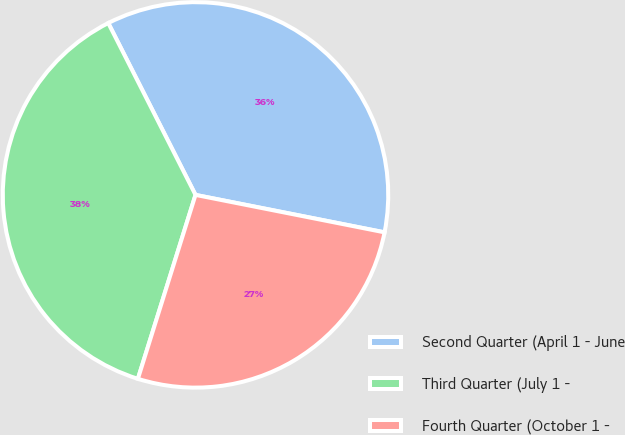Convert chart to OTSL. <chart><loc_0><loc_0><loc_500><loc_500><pie_chart><fcel>Second Quarter (April 1 - June<fcel>Third Quarter (July 1 -<fcel>Fourth Quarter (October 1 -<nl><fcel>35.59%<fcel>37.69%<fcel>26.72%<nl></chart> 